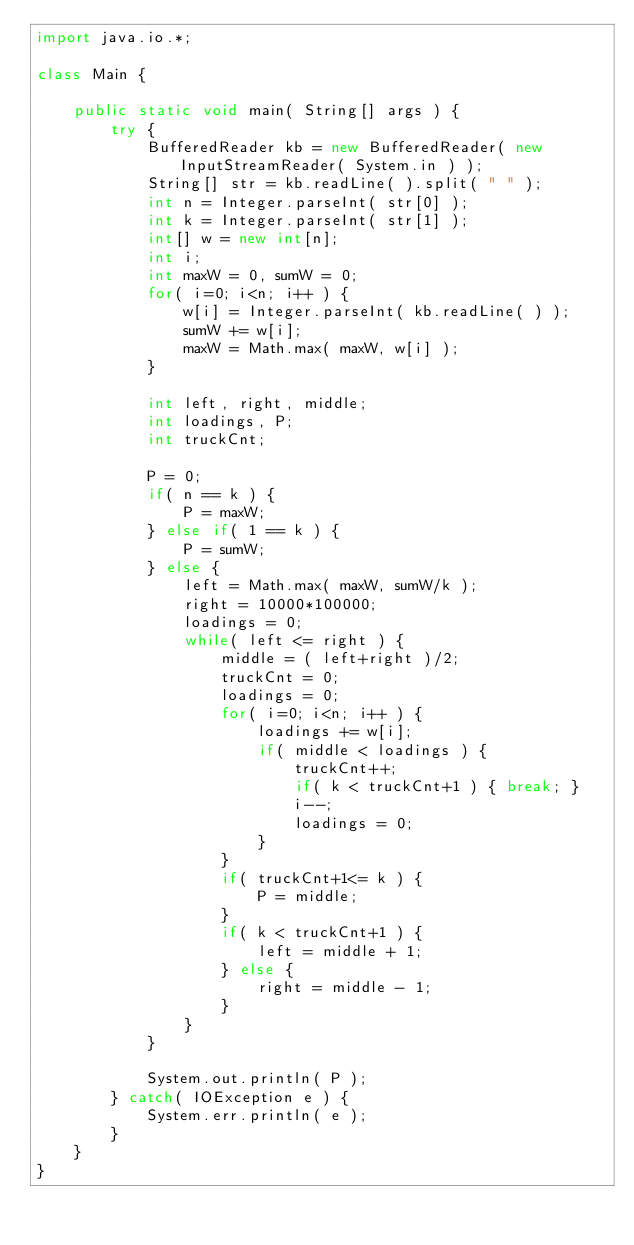<code> <loc_0><loc_0><loc_500><loc_500><_Java_>import java.io.*;

class Main {

    public static void main( String[] args ) {
        try {
	      	BufferedReader kb = new BufferedReader( new InputStreamReader( System.in ) );
			String[] str = kb.readLine( ).split( " " );
        	int n = Integer.parseInt( str[0] );
        	int k = Integer.parseInt( str[1] );
        	int[] w = new int[n];
        	int i;
        	int maxW = 0, sumW = 0;
        	for( i=0; i<n; i++ ) {
        		w[i] = Integer.parseInt( kb.readLine( ) );
        		sumW += w[i];
        		maxW = Math.max( maxW, w[i] );
        	}
        	
        	int left, right, middle;
        	int loadings, P;
        	int truckCnt;
        	
        	P = 0;
        	if( n == k ) {
        		P = maxW;
        	} else if( 1 == k ) {
        		P = sumW;
        	} else {
        		left = Math.max( maxW, sumW/k );
	        	right = 10000*100000;
	        	loadings = 0;
	    		while( left <= right ) {
		        	middle = ( left+right )/2;
					truckCnt = 0;
					loadings = 0;
					for( i=0; i<n; i++ ) {
						loadings += w[i];
						if( middle < loadings ) {
							truckCnt++;
							if( k < truckCnt+1 ) { break; }
							i--;
							loadings = 0;
						}
					}
					if( truckCnt+1<= k ) { 
						P = middle;
					}
					if( k < truckCnt+1 ) {
						left = middle + 1;
					} else {
						right = middle - 1;
					}
	    		}
    		}
    		
			System.out.println( P );
        } catch( IOException e ) {
            System.err.println( e );
        }
    }
}</code> 